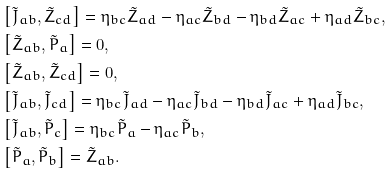Convert formula to latex. <formula><loc_0><loc_0><loc_500><loc_500>& \left [ \tilde { J } _ { a b } , \tilde { Z } _ { c d } \right ] = \eta _ { b c } \tilde { Z } _ { a d } - \eta _ { a c } \tilde { Z } _ { b d } - \eta _ { b d } \tilde { Z } _ { a c } + \eta _ { a d } \tilde { Z } _ { b c } , \\ & \left [ \tilde { Z } _ { a b } , \tilde { P } _ { a } \right ] = 0 , \\ & \left [ \tilde { Z } _ { a b } , \tilde { Z } _ { c d } \right ] = 0 , \\ & \left [ \tilde { J } _ { a b } , \tilde { J } _ { c d } \right ] = \eta _ { b c } \tilde { J } _ { a d } - \eta _ { a c } \tilde { J } _ { b d } - \eta _ { b d } \tilde { J } _ { a c } + \eta _ { a d } \tilde { J } _ { b c } , \\ & \left [ \tilde { J } _ { a b } , \tilde { P } _ { c } \right ] = \eta _ { b c } \tilde { P } _ { a } - \eta _ { a c } \tilde { P } _ { b } , \\ & \left [ \tilde { P } _ { a } , \tilde { P } _ { b } \right ] = \tilde { Z } _ { a b } .</formula> 